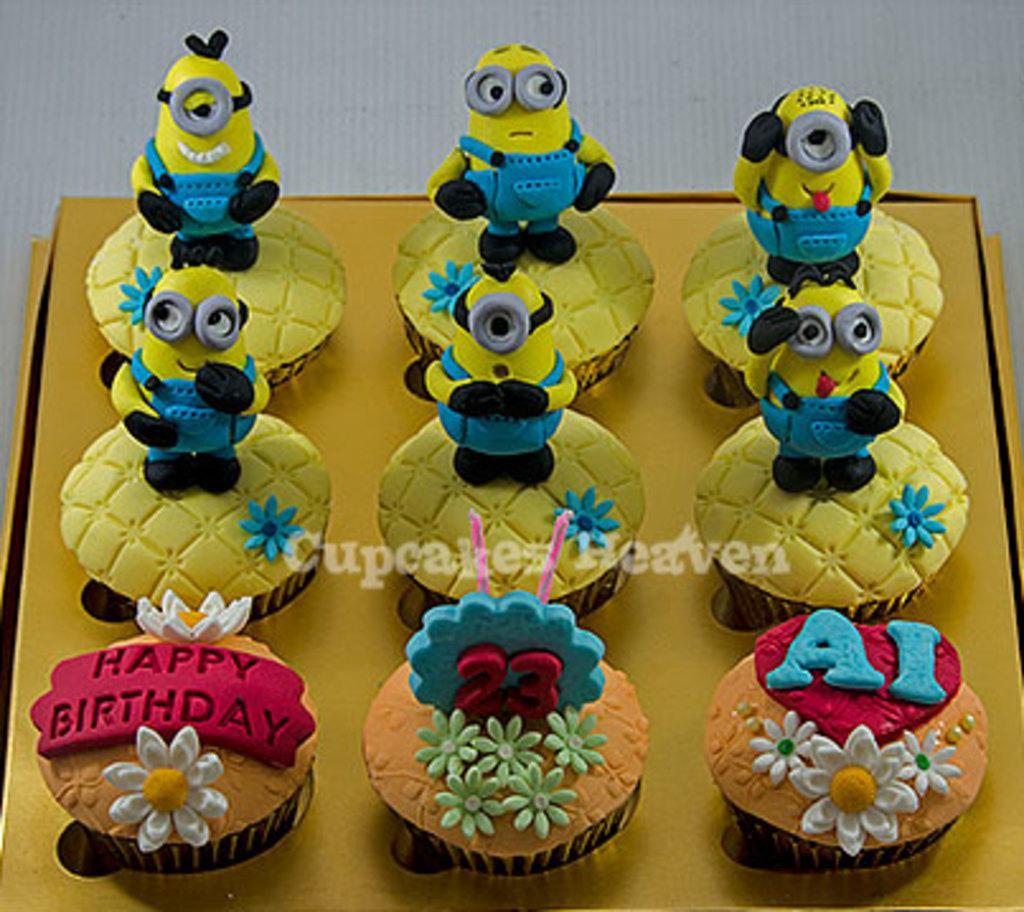How would you summarize this image in a sentence or two? On this yellow surface we can see muffins. On these three muffins there are flowers. Above the middle muffin there are candles. Above these six muffins there are minions.   